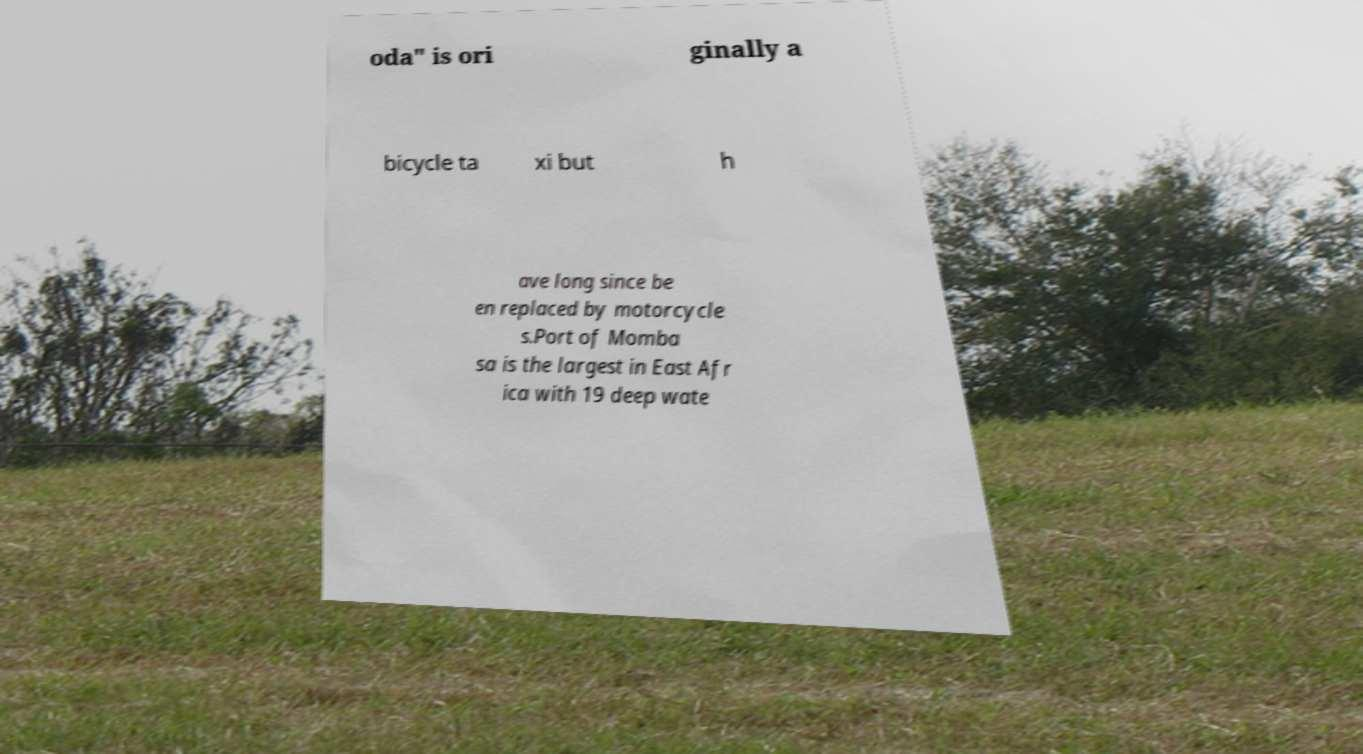I need the written content from this picture converted into text. Can you do that? oda" is ori ginally a bicycle ta xi but h ave long since be en replaced by motorcycle s.Port of Momba sa is the largest in East Afr ica with 19 deep wate 